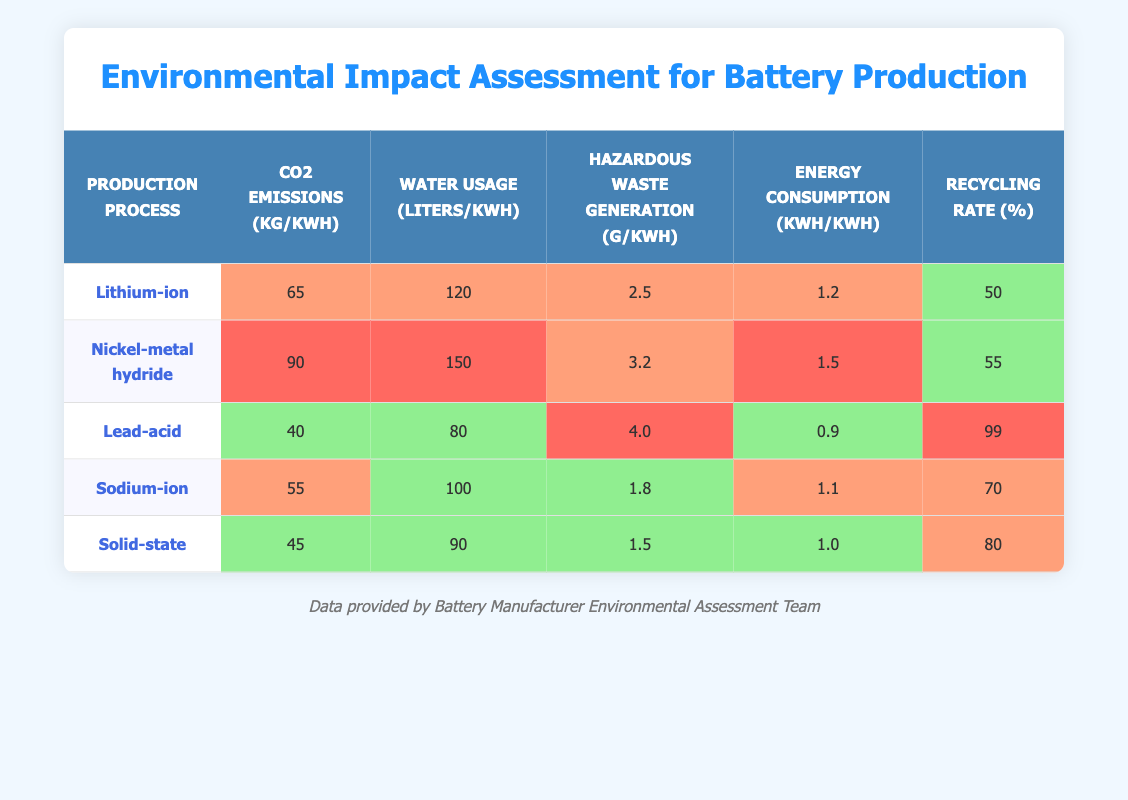What is the CO2 emission for Lithium-ion batteries? The table shows that the CO2 emissions for Lithium-ion batteries is listed as 65 kg/kWh.
Answer: 65 kg/kWh Which production process has the highest water usage? The table indicates that Nickel-metal hydride has the highest water usage at 150 liters/kWh.
Answer: 150 liters/kWh Is the recycling rate for Lead-acid batteries considered low? The table states that the recycling rate for Lead-acid batteries is 99%, which falls in the 'High' category. Therefore, it is not considered low.
Answer: No What is the average hazardous waste generation for all production processes? Summing the hazardous waste values: 2.5 (Lithium-ion) + 3.2 (Nickel-metal hydride) + 4.0 (Lead-acid) + 1.8 (Sodium-ion) + 1.5 (Solid-state) = 13.0 g/kWh. There are 5 production processes, so the average is 13.0 / 5 = 2.6 g/kWh.
Answer: 2.6 g/kWh Which production process has the lowest energy consumption? The energy consumption values are: Lithium-ion (1.2), Nickel-metal hydride (1.5), Lead-acid (0.9), Sodium-ion (1.1), and Solid-state (1.0). Lead-acid, with 0.9 kWh/kWh, has the lowest energy consumption.
Answer: Lead-acid What are the environmental impacts for Solid-state batteries? According to the table, Solid-state batteries have the following impacts: CO2 emissions (45 kg/kWh - Low), water usage (90 liters/kWh - Low), hazardous waste generation (1.5 g/kWh - Low), energy consumption (1.0 kWh/kWh - Low), recycling rate (80% - Medium).
Answer: Low emissions and low water usage, medium recycling rate How do Sodium-ion and Solid-state compare in terms of hazardous waste generation? The table shows Sodium-ion generates 1.8 g/kWh and Solid-state generates 1.5 g/kWh. Sodium-ion has a higher hazardous waste generation compared to Solid-state.
Answer: Sodium-ion generates more hazardous waste What is the difference in recycling rates between Nickel-metal hydride and Solid-state processes? The recycling rates are: Nickel-metal hydride (55%) and Solid-state (80%). The difference is 80 - 55 = 25%.
Answer: 25% 